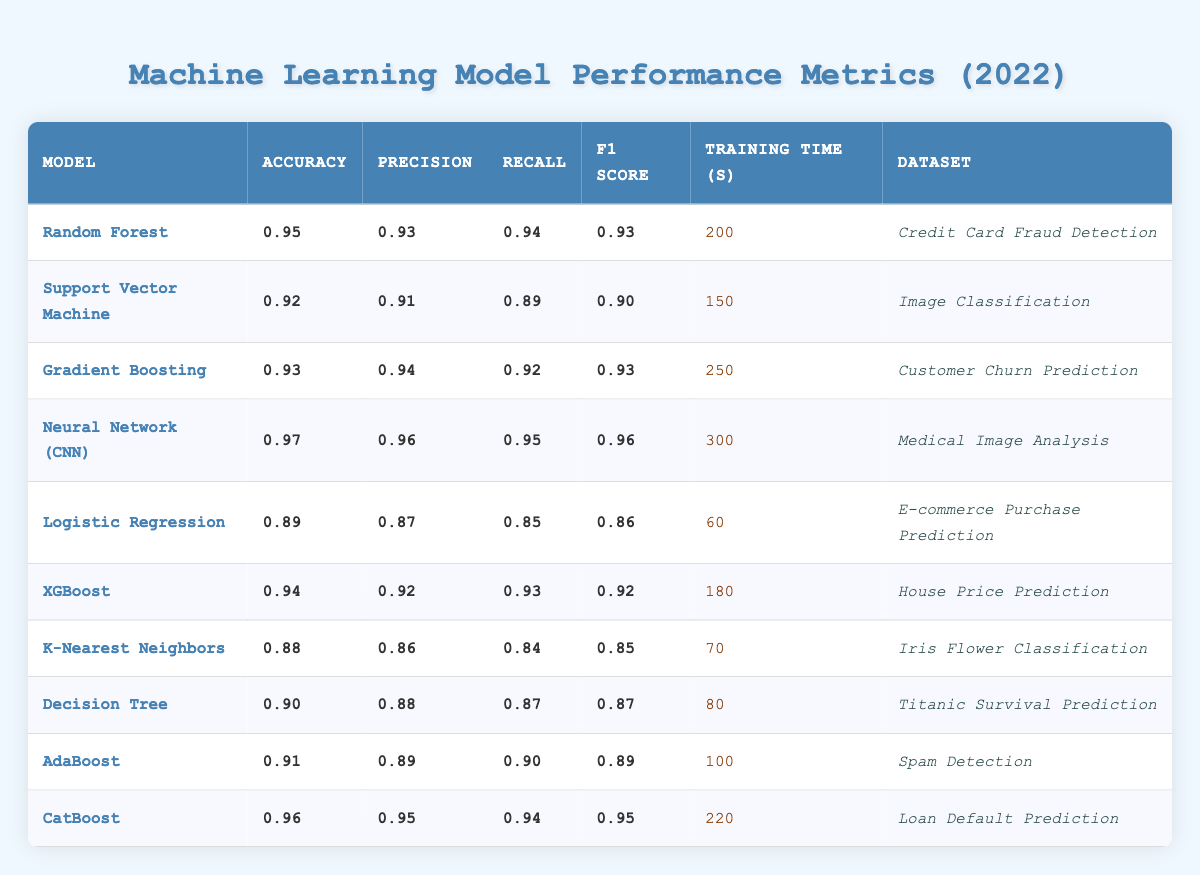What is the accuracy of the Neural Network (CNN) model? The Neural Network (CNN) model has a listed accuracy of 0.97 in the table.
Answer: 0.97 Which model has the longest training time? The model with the longest training time is the Neural Network (CNN), which takes 300 seconds.
Answer: Neural Network (CNN) What is the F1 Score of the Random Forest model? The F1 Score for the Random Forest model is 0.93, as stated in the table.
Answer: 0.93 Which model has the highest precision and what is that value? The Neural Network (CNN) model has the highest precision of 0.96 according to the table.
Answer: 0.96 Is the accuracy of XGBoost greater than that of Support Vector Machine? Yes, XGBoost has an accuracy of 0.94, which is greater than the Support Vector Machine's accuracy of 0.92.
Answer: Yes What is the average training time for all the models listed? The total training time for all models is 200 + 150 + 250 + 300 + 60 + 180 + 70 + 80 + 100 + 220 = 1710 seconds. There are 10 models, so the average training time is 1710 / 10 = 171 seconds.
Answer: 171 seconds Which models have an F1 Score greater than 0.90? The models with an F1 Score greater than 0.90 are Random Forest (0.93), Gradient Boosting (0.93), Neural Network (CNN) (0.96), XGBoost (0.92), CatBoost (0.95), and AdaBoost (0.89).
Answer: 5 models What is the difference in accuracy between the K-Nearest Neighbors model and the Decision Tree model? The K-Nearest Neighbors model has an accuracy of 0.88, while the Decision Tree model has an accuracy of 0.90. The difference in accuracy is 0.90 - 0.88 = 0.02.
Answer: 0.02 Which dataset is used by the model with the lowest accuracy? The model with the lowest accuracy is the Logistic Regression, which has an accuracy of 0.89 and uses the E-commerce Purchase Prediction dataset.
Answer: E-commerce Purchase Prediction How many models are evaluated on the Credit Card Fraud Detection dataset? Only one model, the Random Forest, is evaluated on the Credit Card Fraud Detection dataset, as shown in the data.
Answer: 1 model 